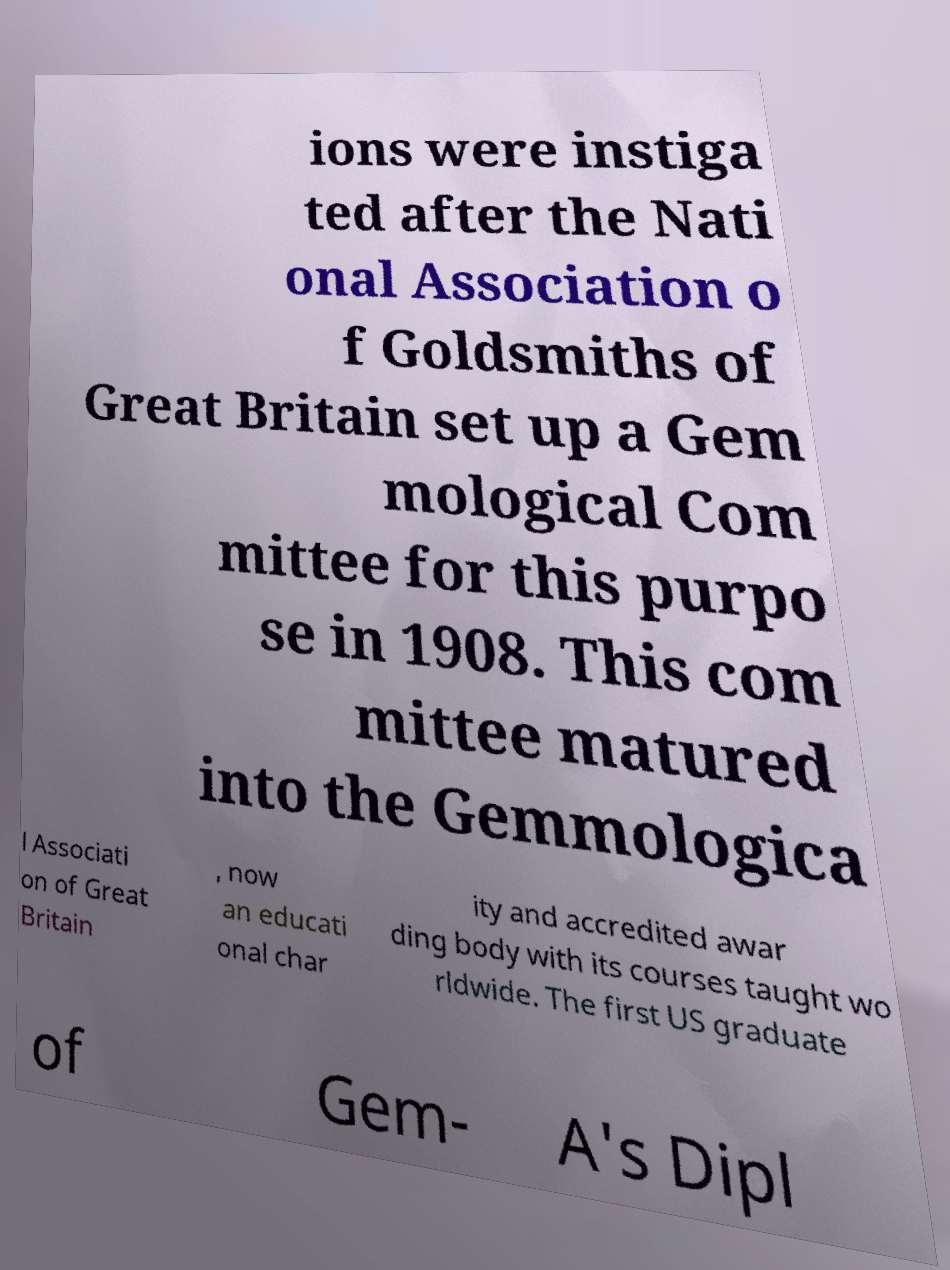Could you extract and type out the text from this image? ions were instiga ted after the Nati onal Association o f Goldsmiths of Great Britain set up a Gem mological Com mittee for this purpo se in 1908. This com mittee matured into the Gemmologica l Associati on of Great Britain , now an educati onal char ity and accredited awar ding body with its courses taught wo rldwide. The first US graduate of Gem- A's Dipl 